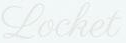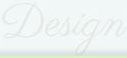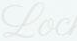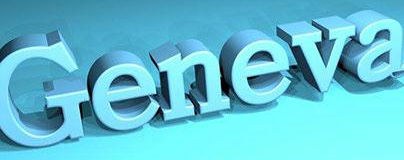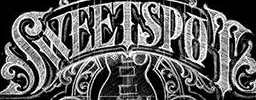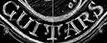What text is displayed in these images sequentially, separated by a semicolon? Locket; Design; Loc; Geneva; SWEETSPOT; GUITARS 